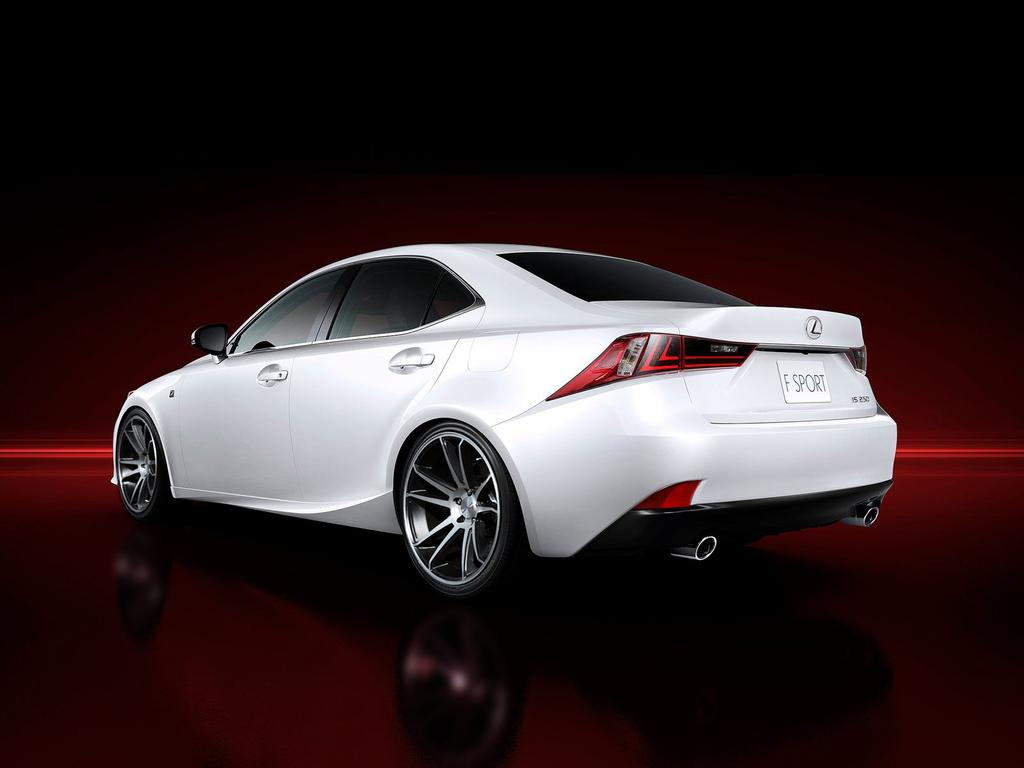What type of vehicle can be seen in the background of the image? There is a car in the background of the image. Can you describe the color of the car? The car appears to be dark red. What type of representative is standing next to the car in the image? There is no representative present in the image; it only features a car in the background. 